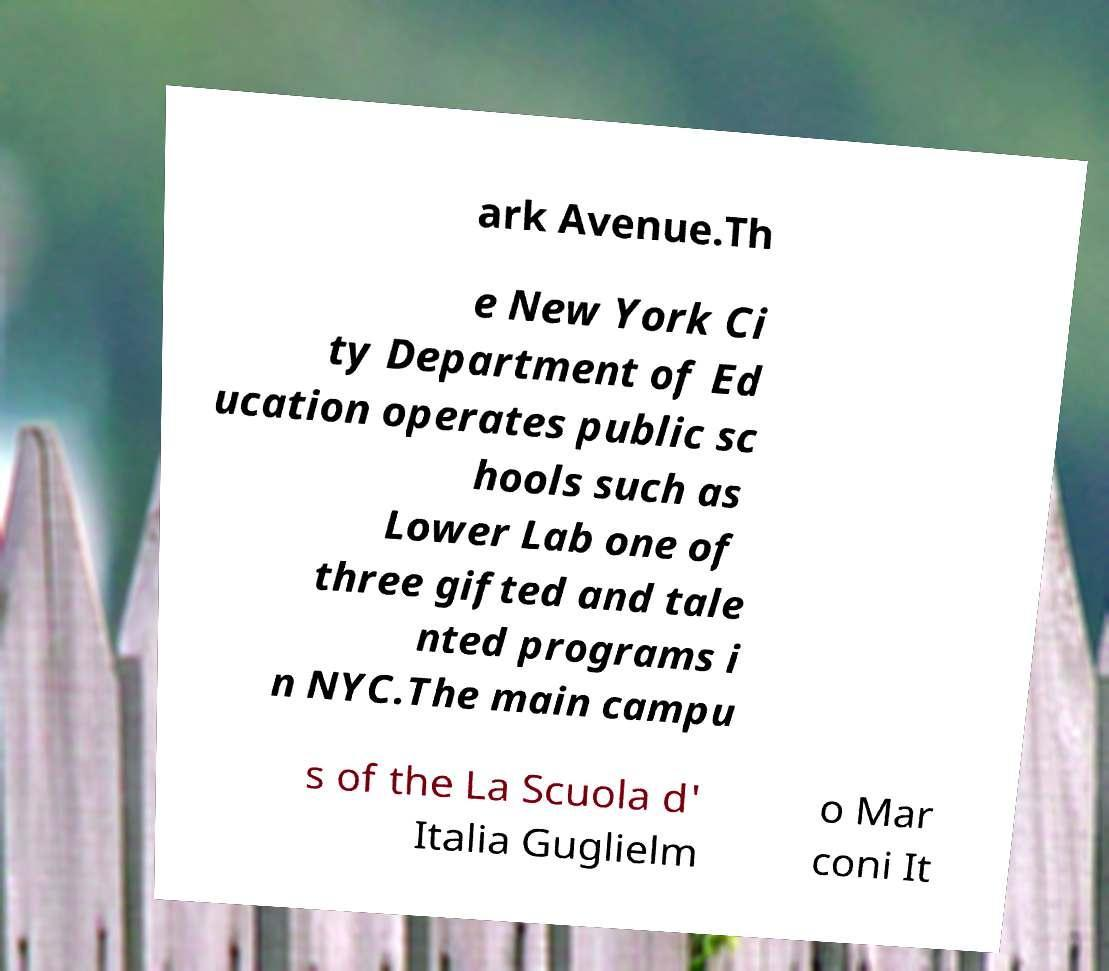I need the written content from this picture converted into text. Can you do that? ark Avenue.Th e New York Ci ty Department of Ed ucation operates public sc hools such as Lower Lab one of three gifted and tale nted programs i n NYC.The main campu s of the La Scuola d' Italia Guglielm o Mar coni It 